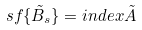<formula> <loc_0><loc_0><loc_500><loc_500>s f \{ \tilde { B } _ { s } \} = i n d e x \tilde { A }</formula> 